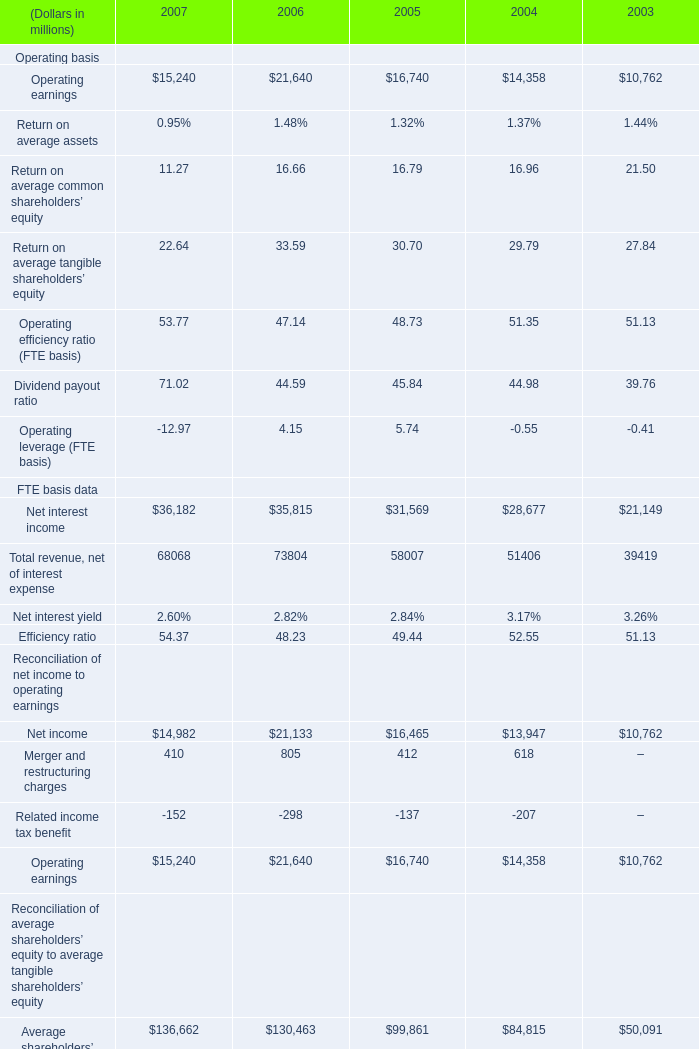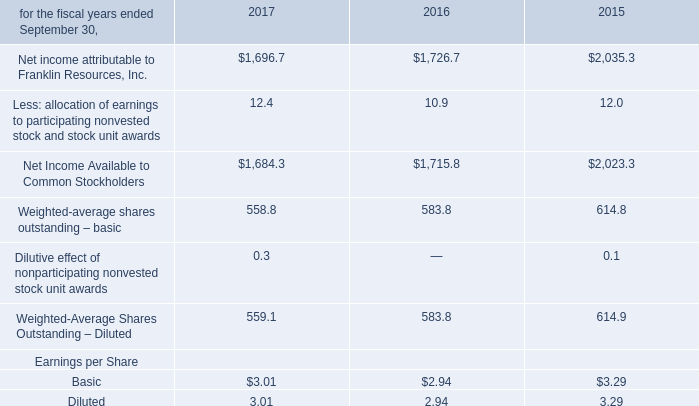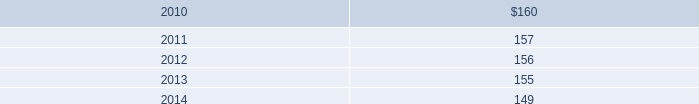what is the 2010 estimated amortization expense for finite-lived intangible assets as a percentage of the unsecured revolving credit facility? 
Computations: (2.5 / 1000)
Answer: 0.0025. 